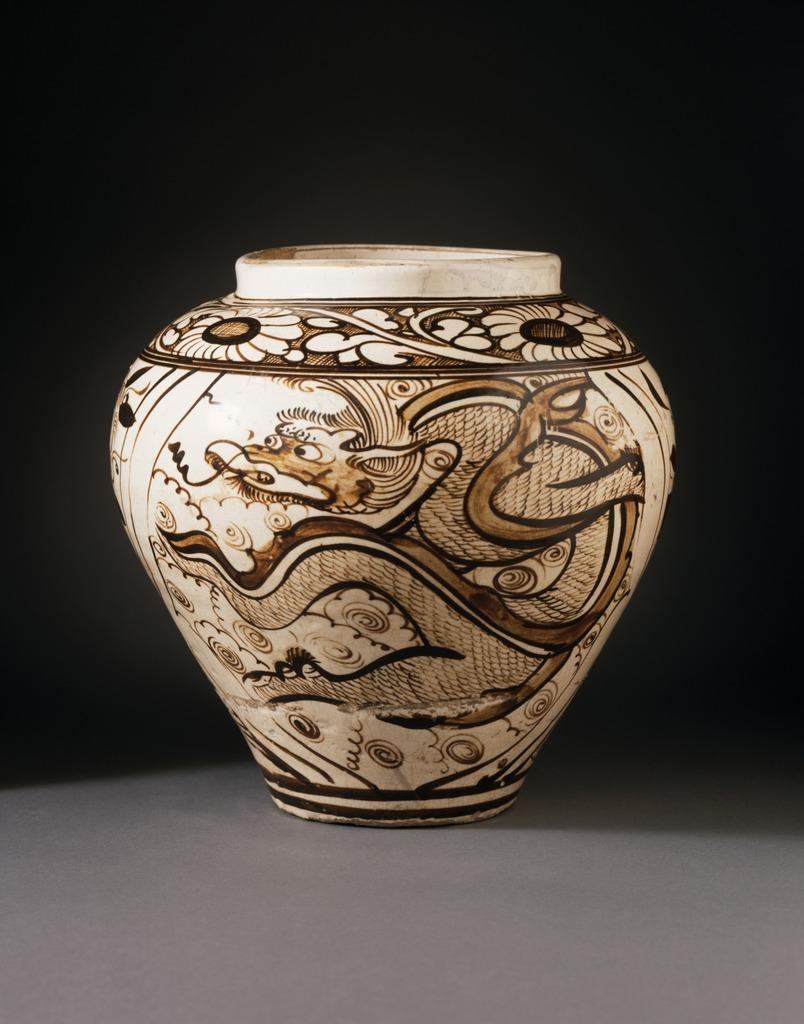Describe this image in one or two sentences. In this picture we can see a pot and there is a painting on it. Background portion of the picture is dark. 